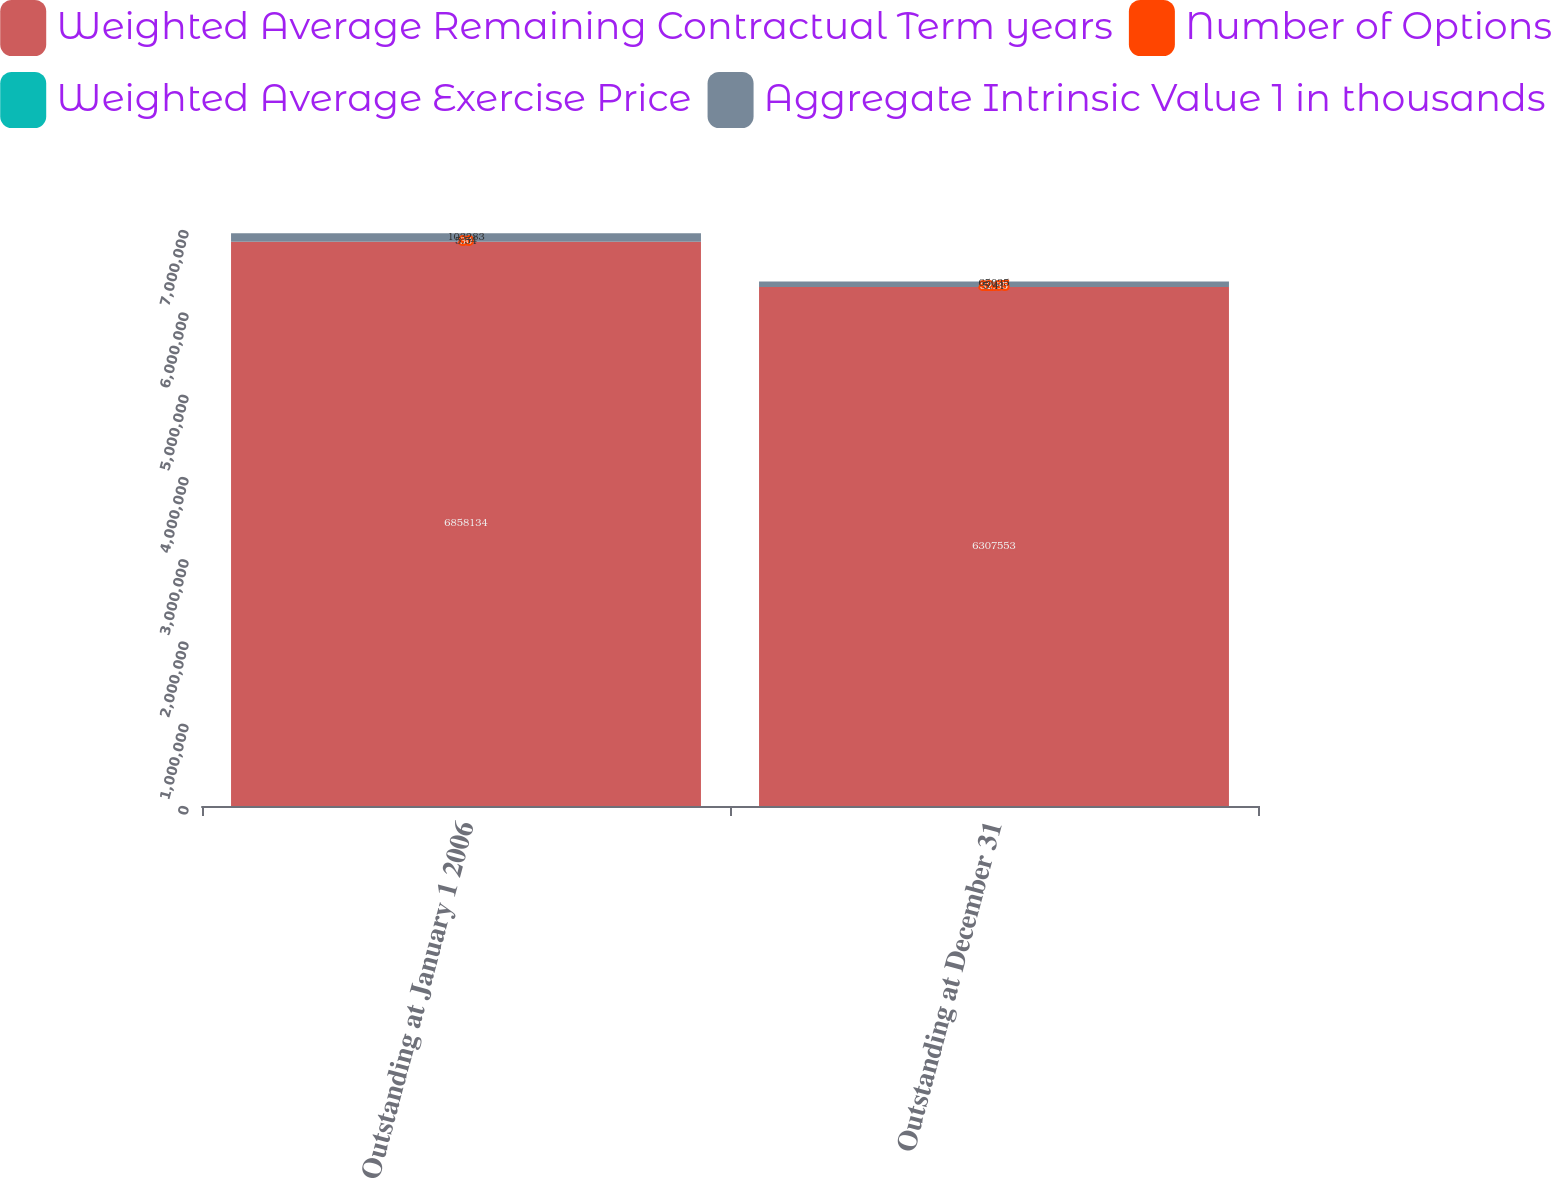<chart> <loc_0><loc_0><loc_500><loc_500><stacked_bar_chart><ecel><fcel>Outstanding at January 1 2006<fcel>Outstanding at December 31<nl><fcel>Weighted Average Remaining Contractual Term years<fcel>6.85813e+06<fcel>6.30755e+06<nl><fcel>Number of Options<fcel>30<fcel>32.85<nl><fcel>Weighted Average Exercise Price<fcel>5.54<fcel>5.41<nl><fcel>Aggregate Intrinsic Value 1 in thousands<fcel>103283<fcel>65035<nl></chart> 